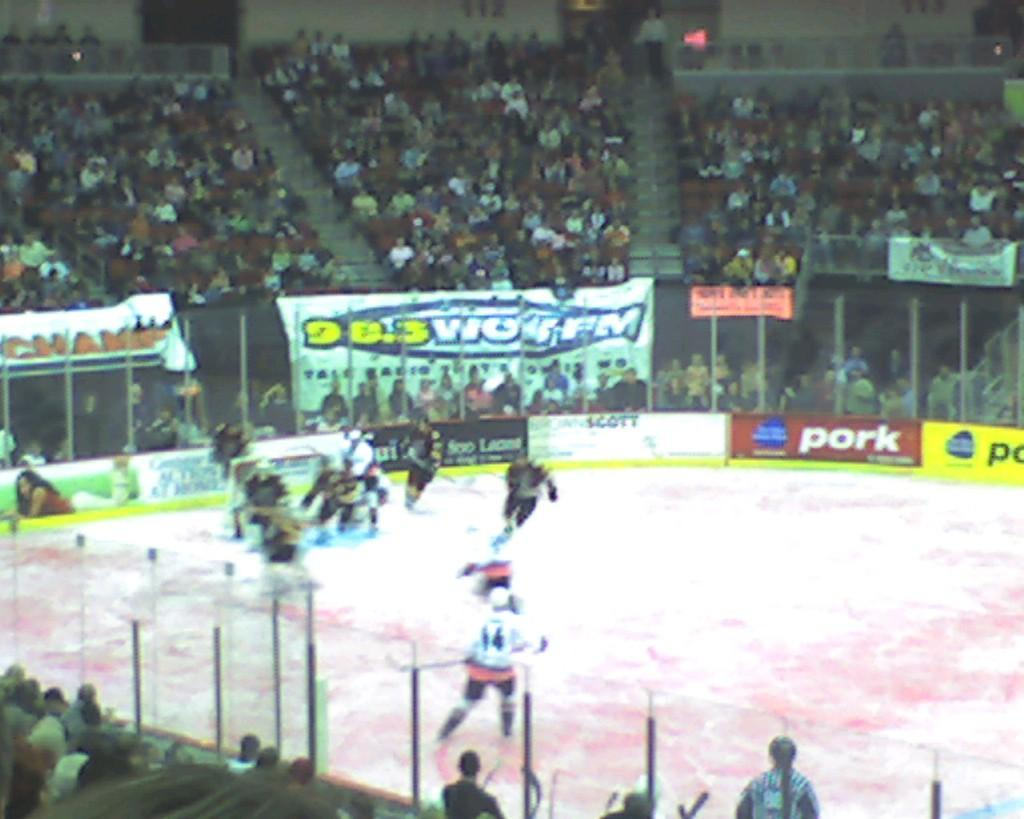<image>
Offer a succinct explanation of the picture presented. Hockey players competing in a stadium with an ad that says PORK. 